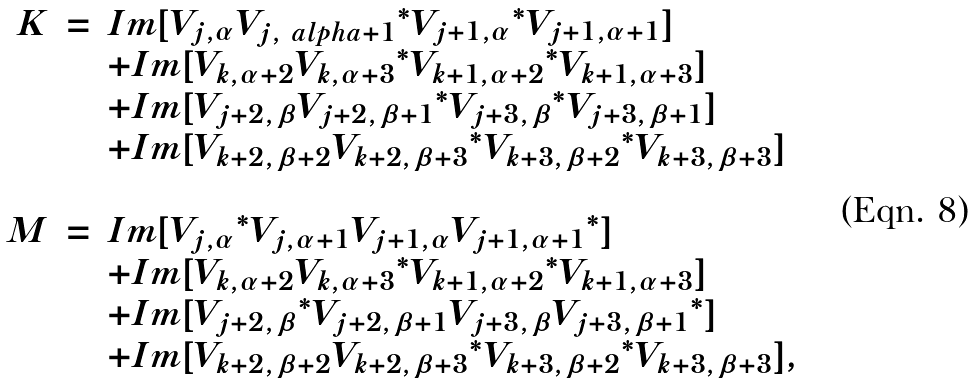<formula> <loc_0><loc_0><loc_500><loc_500>\begin{array} { r c l } K & = & I m [ V _ { j , \alpha } { V _ { j , \ a l p h a + 1 } } ^ { * } { V _ { j + 1 , \alpha } } ^ { * } V _ { j + 1 , \alpha + 1 } ] \\ & & + I m [ V _ { k , \alpha + 2 } { V _ { k , \alpha + 3 } } ^ { * } { V _ { k + 1 , \alpha + 2 } } ^ { * } V _ { k + 1 , \alpha + 3 } ] \\ & & + I m [ V _ { j + 2 , \beta } { V _ { j + 2 , \beta + 1 } } ^ { * } { V _ { j + 3 , \beta } } ^ { * } V _ { j + 3 , \beta + 1 } ] \\ & & + I m [ V _ { k + 2 , \beta + 2 } { V _ { k + 2 , \beta + 3 } } ^ { * } { V _ { k + 3 , \beta + 2 } } ^ { * } V _ { k + 3 , \beta + 3 } ] \\ & & \\ M & = & I m [ { V _ { j , \alpha } } ^ { * } V _ { j , \alpha + 1 } V _ { j + 1 , \alpha } { V _ { j + 1 , \alpha + 1 } } ^ { * } ] \\ & & + I m [ V _ { k , \alpha + 2 } { V _ { k , \alpha + 3 } } ^ { * } { V _ { k + 1 , \alpha + 2 } } ^ { * } V _ { k + 1 , \alpha + 3 } ] \\ & & + I m [ { V _ { j + 2 , \beta } } ^ { * } V _ { j + 2 , \beta + 1 } V _ { j + 3 , \beta } { V _ { j + 3 , \beta + 1 } } ^ { * } ] \\ & & + I m [ V _ { k + 2 , \beta + 2 } { V _ { k + 2 , \beta + 3 } } ^ { * } { V _ { k + 3 , \beta + 2 } } ^ { * } V _ { k + 3 , \beta + 3 } ] , \\ & & \end{array}</formula> 